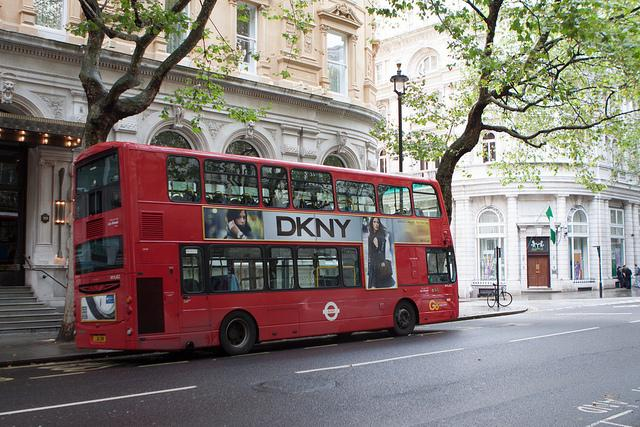What state is the company from whose logo appears on the bus?

Choices:
A) new york
B) missouri
C) oklahoma
D) michigan new york 